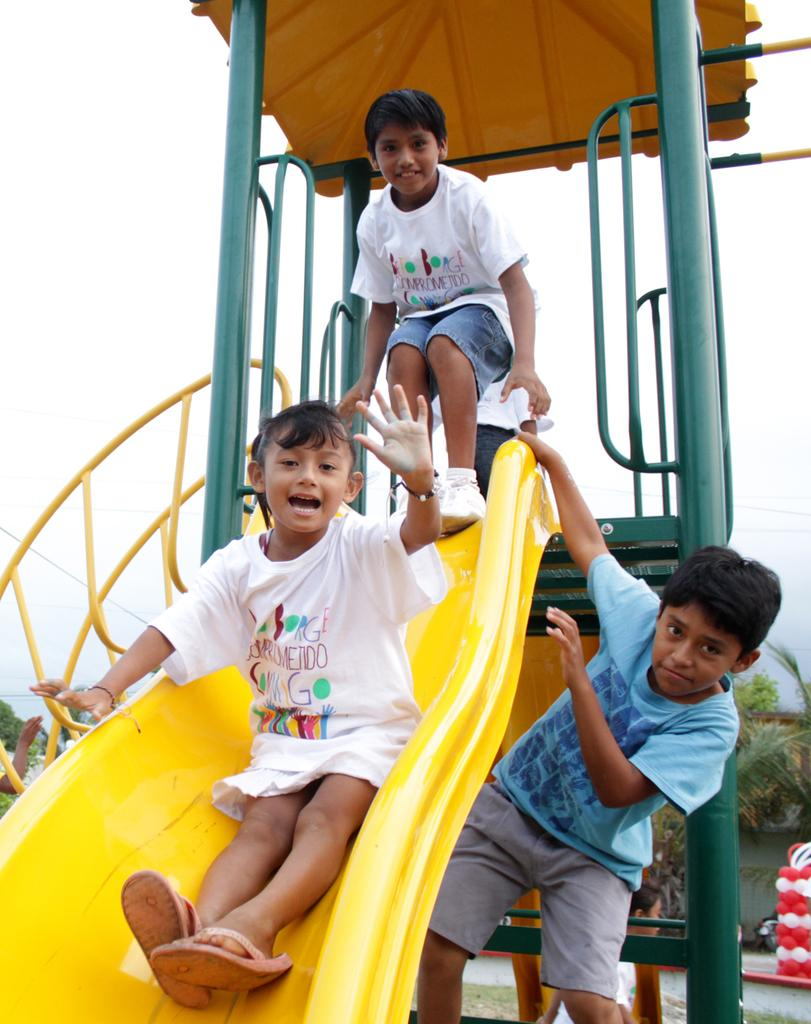What are the people in the image doing? The people in the image are playing. What are they playing on? They are playing on a slide. What can be seen in the background of the image? There is sky and trees visible in the background of the image. What type of jeans are the people wearing while playing at the zoo in the image? There is no mention of jeans or a zoo in the image, so we cannot determine what type of jeans the people might be wearing. 